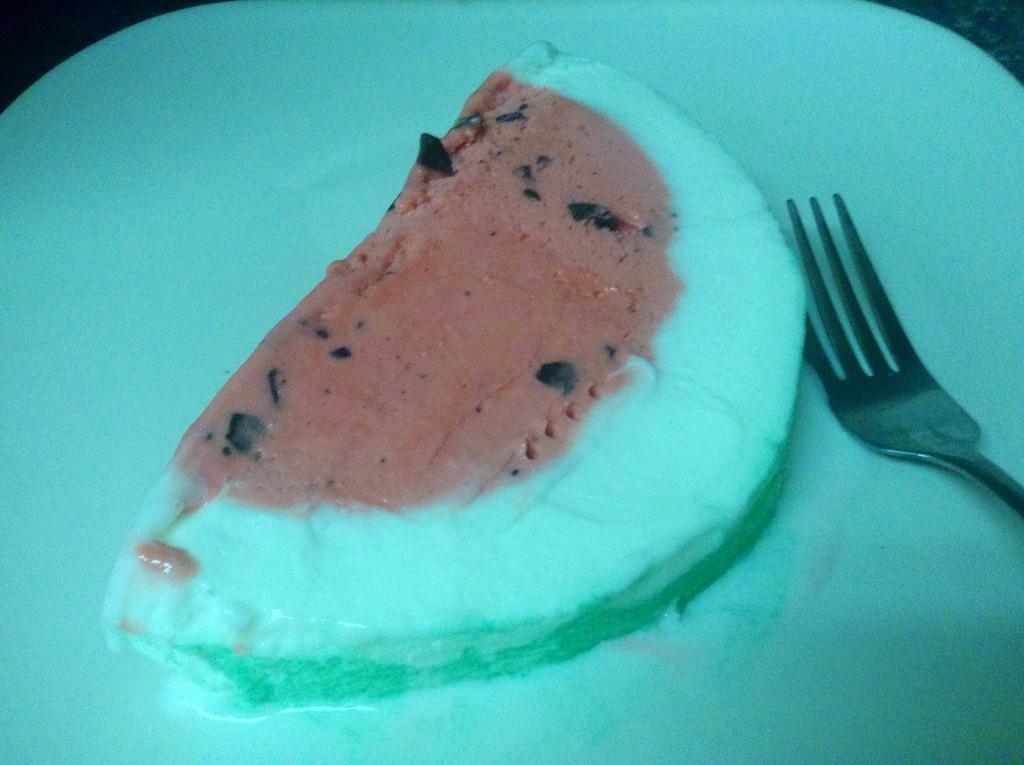Describe this image in one or two sentences. In this picture there is food and there is a fork on the white plate. 